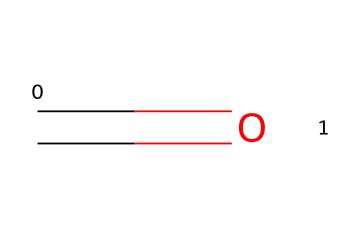What is the functional group present in this chemical? The chemical structure contains a carbonyl group (C=O), which indicates that this is an aldehyde or ketone. In this case, it is commonly associated with formaldehyde.
Answer: carbonyl group How many atoms are present in this chemical structure? An analysis of the SMILES indicates there is one carbon atom and one oxygen atom, totaling two atoms in the structure.
Answer: 2 What type of chemical is this? The presence of the carbonyl group classifies this chemical as an aldehyde, as it has a carbonyl with at least one hydrogen atom attached to the carbon.
Answer: aldehyde Does this chemical release formaldehyde? Given that this structure corresponds to formaldehyde (C=O), which is used in various preservatives, the answer is yes.
Answer: yes What is the primary use of this chemical in cosmetics? Formaldehyde-releasing preservatives are mainly used to prevent microbial growth in cosmetic products, thereby extending their shelf life.
Answer: preservative How many double bonds are present in this chemical? The structure shows one double bond between carbon and oxygen, indicating a single carbonyl functional group.
Answer: 1 